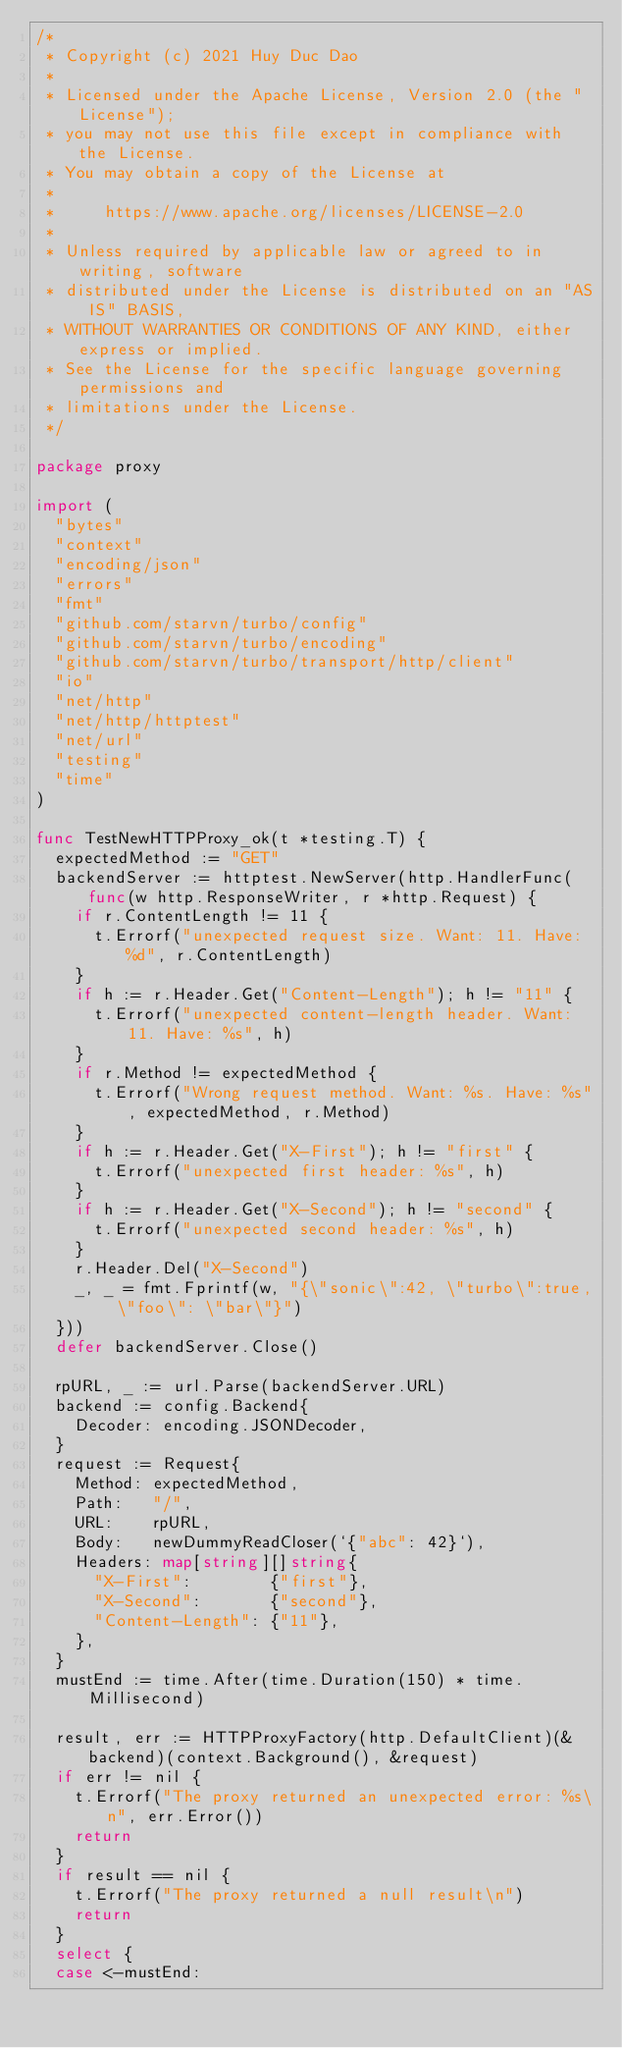Convert code to text. <code><loc_0><loc_0><loc_500><loc_500><_Go_>/*
 * Copyright (c) 2021 Huy Duc Dao
 *
 * Licensed under the Apache License, Version 2.0 (the "License");
 * you may not use this file except in compliance with the License.
 * You may obtain a copy of the License at
 *
 *     https://www.apache.org/licenses/LICENSE-2.0
 *
 * Unless required by applicable law or agreed to in writing, software
 * distributed under the License is distributed on an "AS IS" BASIS,
 * WITHOUT WARRANTIES OR CONDITIONS OF ANY KIND, either express or implied.
 * See the License for the specific language governing permissions and
 * limitations under the License.
 */

package proxy

import (
	"bytes"
	"context"
	"encoding/json"
	"errors"
	"fmt"
	"github.com/starvn/turbo/config"
	"github.com/starvn/turbo/encoding"
	"github.com/starvn/turbo/transport/http/client"
	"io"
	"net/http"
	"net/http/httptest"
	"net/url"
	"testing"
	"time"
)

func TestNewHTTPProxy_ok(t *testing.T) {
	expectedMethod := "GET"
	backendServer := httptest.NewServer(http.HandlerFunc(func(w http.ResponseWriter, r *http.Request) {
		if r.ContentLength != 11 {
			t.Errorf("unexpected request size. Want: 11. Have: %d", r.ContentLength)
		}
		if h := r.Header.Get("Content-Length"); h != "11" {
			t.Errorf("unexpected content-length header. Want: 11. Have: %s", h)
		}
		if r.Method != expectedMethod {
			t.Errorf("Wrong request method. Want: %s. Have: %s", expectedMethod, r.Method)
		}
		if h := r.Header.Get("X-First"); h != "first" {
			t.Errorf("unexpected first header: %s", h)
		}
		if h := r.Header.Get("X-Second"); h != "second" {
			t.Errorf("unexpected second header: %s", h)
		}
		r.Header.Del("X-Second")
		_, _ = fmt.Fprintf(w, "{\"sonic\":42, \"turbo\":true, \"foo\": \"bar\"}")
	}))
	defer backendServer.Close()

	rpURL, _ := url.Parse(backendServer.URL)
	backend := config.Backend{
		Decoder: encoding.JSONDecoder,
	}
	request := Request{
		Method: expectedMethod,
		Path:   "/",
		URL:    rpURL,
		Body:   newDummyReadCloser(`{"abc": 42}`),
		Headers: map[string][]string{
			"X-First":        {"first"},
			"X-Second":       {"second"},
			"Content-Length": {"11"},
		},
	}
	mustEnd := time.After(time.Duration(150) * time.Millisecond)

	result, err := HTTPProxyFactory(http.DefaultClient)(&backend)(context.Background(), &request)
	if err != nil {
		t.Errorf("The proxy returned an unexpected error: %s\n", err.Error())
		return
	}
	if result == nil {
		t.Errorf("The proxy returned a null result\n")
		return
	}
	select {
	case <-mustEnd:</code> 